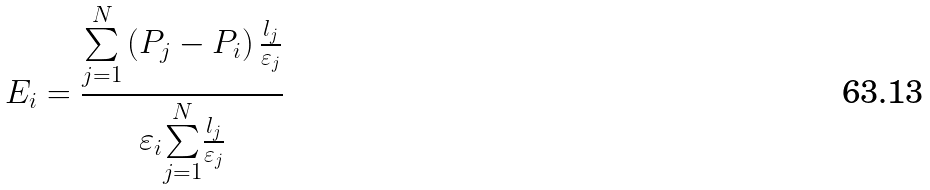Convert formula to latex. <formula><loc_0><loc_0><loc_500><loc_500>E _ { i } = \frac { \overset { N } { \underset { j = 1 } { \sum } } \left ( P _ { j } - P _ { i } \right ) \frac { l _ { j } } { \varepsilon _ { j } } } { \varepsilon _ { i } \overset { N } { \underset { j = 1 } { \sum } } \frac { l _ { j } } { \varepsilon _ { j } } }</formula> 